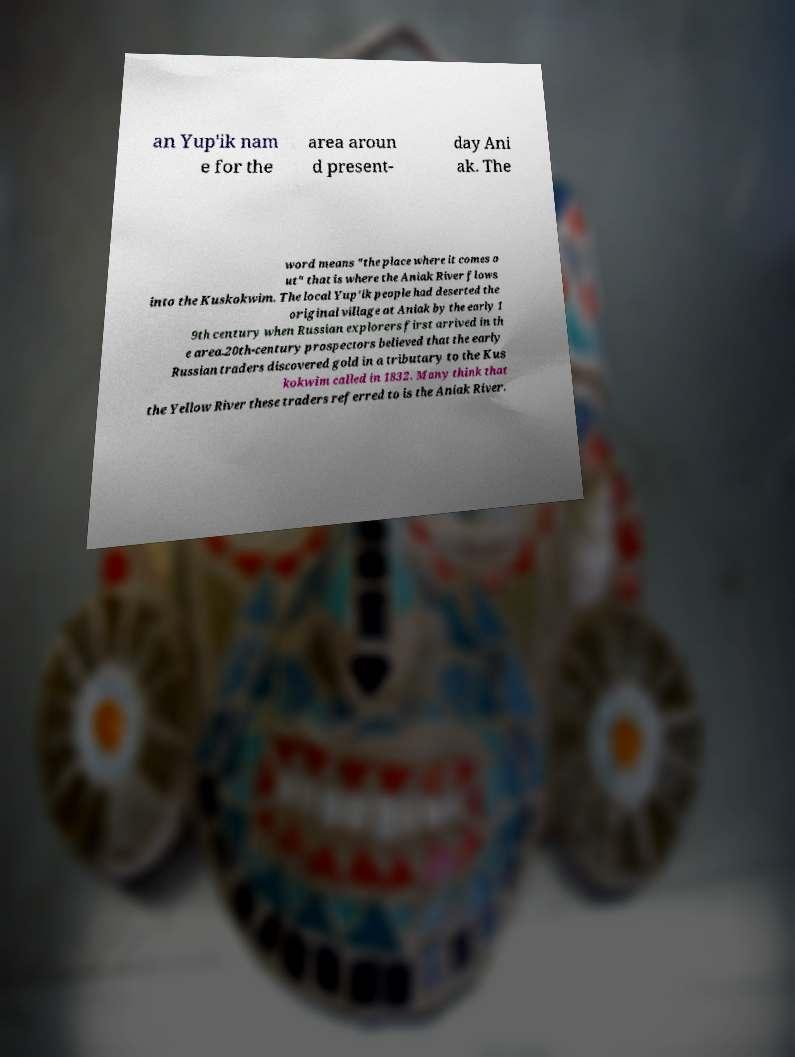Please read and relay the text visible in this image. What does it say? an Yup'ik nam e for the area aroun d present- day Ani ak. The word means "the place where it comes o ut" that is where the Aniak River flows into the Kuskokwim. The local Yup'ik people had deserted the original village at Aniak by the early 1 9th century when Russian explorers first arrived in th e area.20th-century prospectors believed that the early Russian traders discovered gold in a tributary to the Kus kokwim called in 1832. Many think that the Yellow River these traders referred to is the Aniak River. 